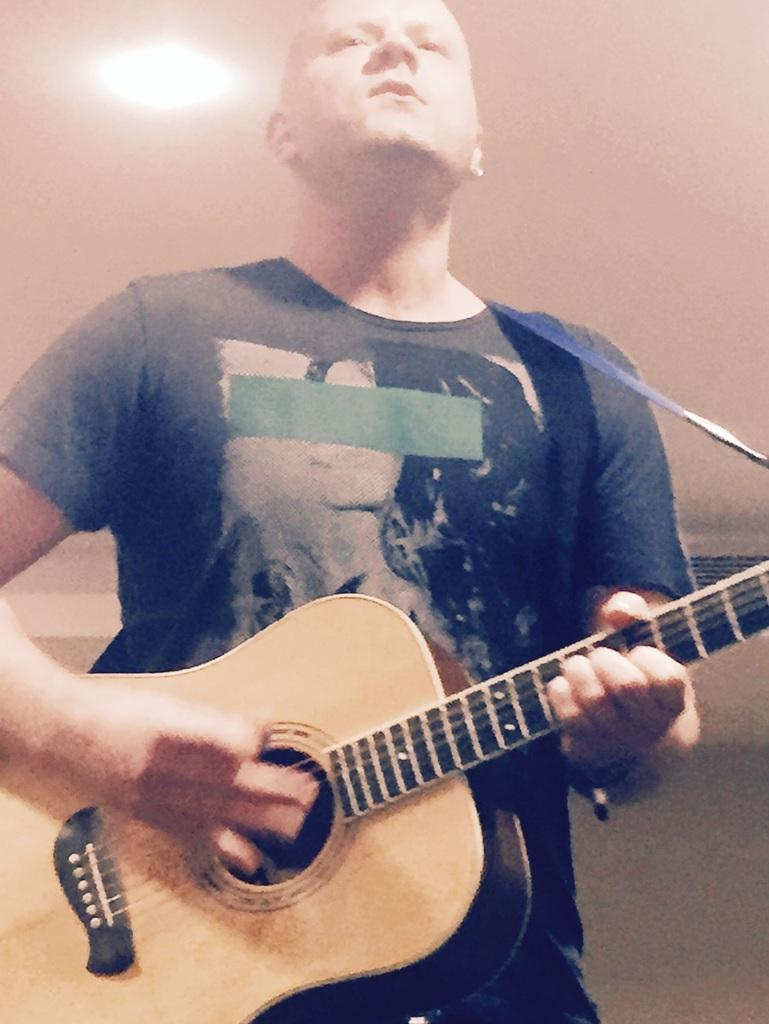What is the main subject of the image? There is a man in the image. What is the man wearing? The man is wearing a black t-shirt. What is the man doing in the image? The man is standing and playing the guitar. What can be seen in the background of the image? There is a wall in the background of the image. What is the source of light in the image? There is a light at the top of the image. How much coal is being used by the man to play the guitar in the image? There is no coal present in the image, and the man is playing the guitar without any coal. What type of knot is the man using to hold the guitar in the image? The man is not using a knot to hold the guitar; he is playing it with his hands. 